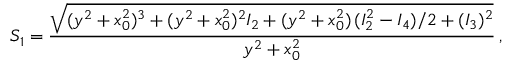<formula> <loc_0><loc_0><loc_500><loc_500>S _ { 1 } = \frac { \sqrt { ( y ^ { 2 } + x _ { 0 } ^ { 2 } ) ^ { 3 } + ( y ^ { 2 } + x _ { 0 } ^ { 2 } ) ^ { 2 } I _ { 2 } + ( y ^ { 2 } + x _ { 0 } ^ { 2 } ) \, ( I _ { 2 } ^ { 2 } - I _ { 4 } ) / 2 + ( I _ { 3 } ) ^ { 2 } } } { y ^ { 2 } + x _ { 0 } ^ { 2 } } \, ,</formula> 